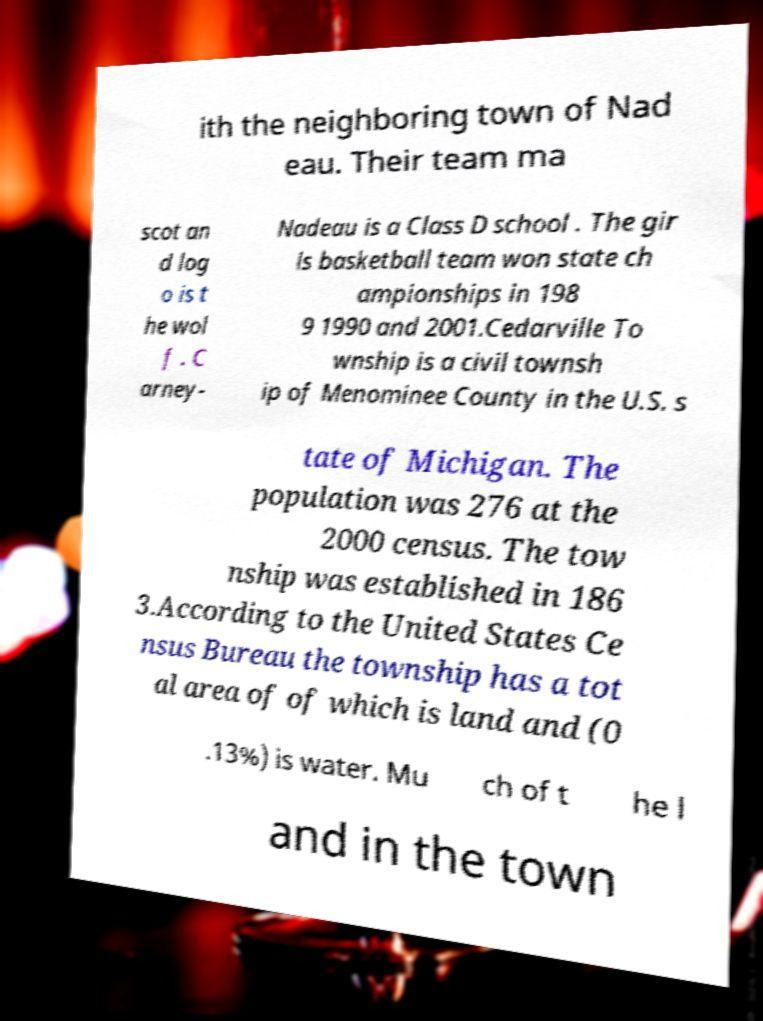I need the written content from this picture converted into text. Can you do that? ith the neighboring town of Nad eau. Their team ma scot an d log o is t he wol f . C arney- Nadeau is a Class D school . The gir ls basketball team won state ch ampionships in 198 9 1990 and 2001.Cedarville To wnship is a civil townsh ip of Menominee County in the U.S. s tate of Michigan. The population was 276 at the 2000 census. The tow nship was established in 186 3.According to the United States Ce nsus Bureau the township has a tot al area of of which is land and (0 .13%) is water. Mu ch of t he l and in the town 